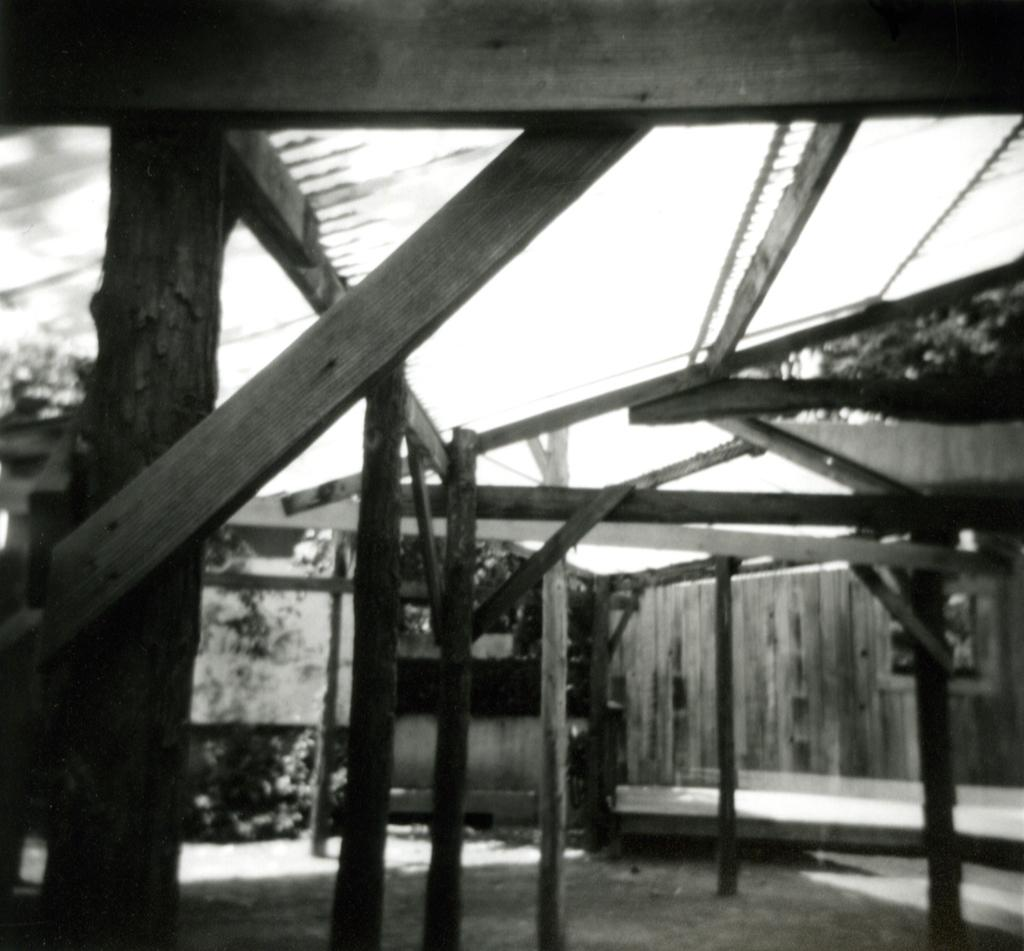What objects can be seen in the image that are made of wood? There are wooden sticks in the image. What type of structure is visible in the image? There is a shed in the image. What can be seen in the background of the image? There are plants and trees in the background of the image. Can you hear the clam laughing in the image? There is no clam or laughter present in the image. 